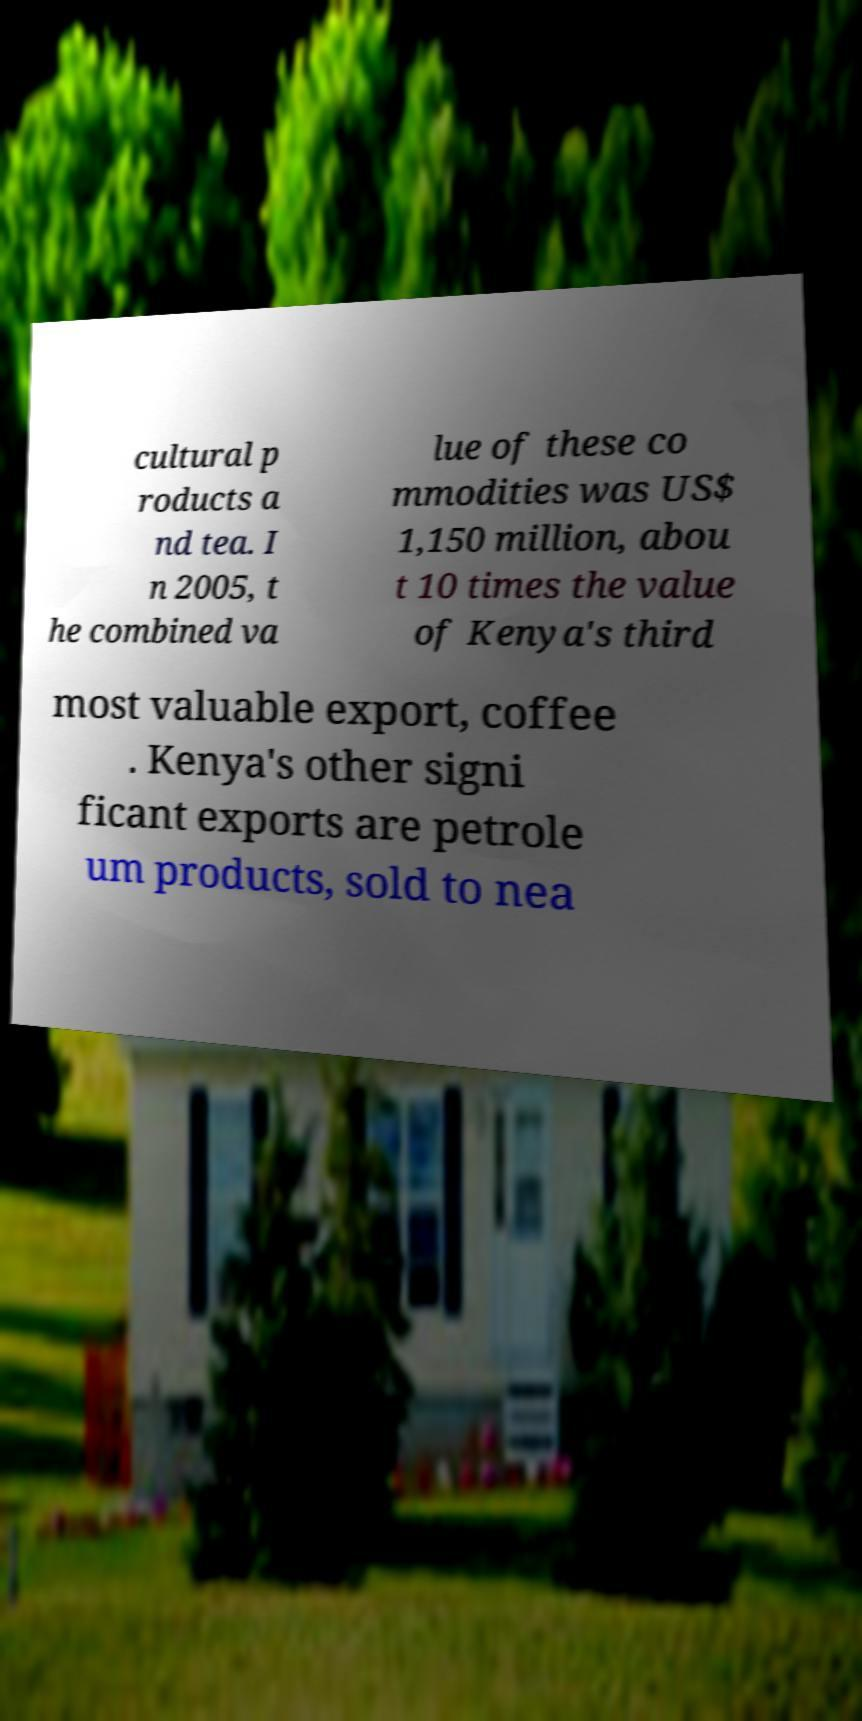Please identify and transcribe the text found in this image. cultural p roducts a nd tea. I n 2005, t he combined va lue of these co mmodities was US$ 1,150 million, abou t 10 times the value of Kenya's third most valuable export, coffee . Kenya's other signi ficant exports are petrole um products, sold to nea 